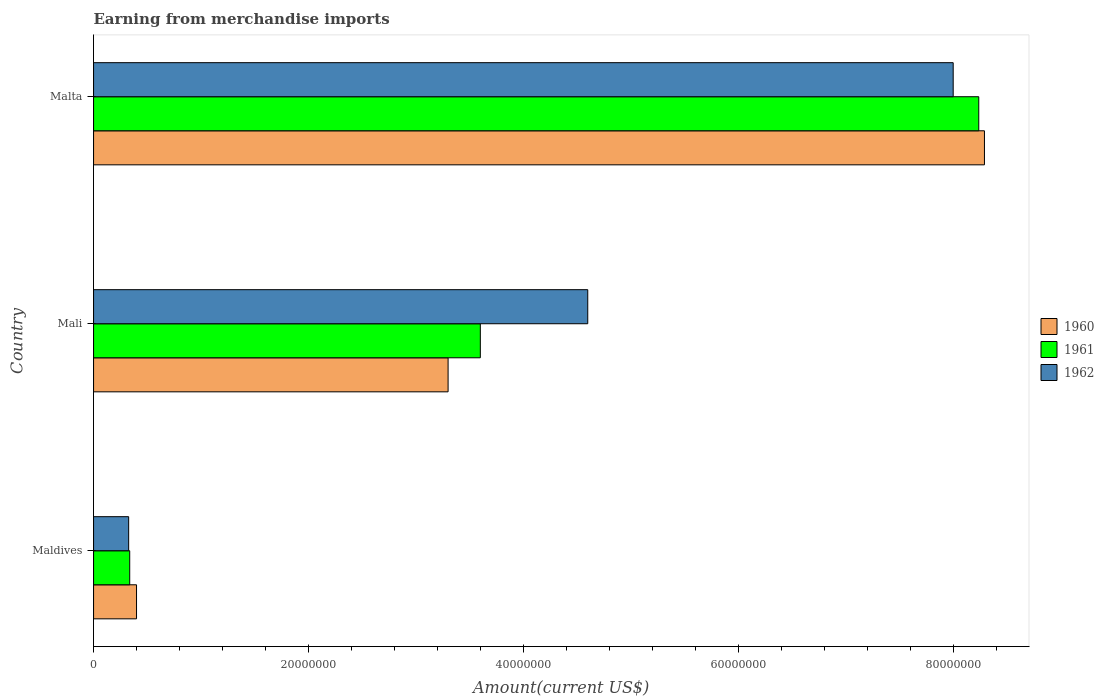How many different coloured bars are there?
Offer a very short reply. 3. Are the number of bars per tick equal to the number of legend labels?
Make the answer very short. Yes. How many bars are there on the 2nd tick from the top?
Your response must be concise. 3. What is the label of the 3rd group of bars from the top?
Give a very brief answer. Maldives. In how many cases, is the number of bars for a given country not equal to the number of legend labels?
Offer a very short reply. 0. What is the amount earned from merchandise imports in 1961 in Malta?
Ensure brevity in your answer.  8.24e+07. Across all countries, what is the maximum amount earned from merchandise imports in 1962?
Your response must be concise. 8.00e+07. Across all countries, what is the minimum amount earned from merchandise imports in 1961?
Offer a terse response. 3.37e+06. In which country was the amount earned from merchandise imports in 1961 maximum?
Make the answer very short. Malta. In which country was the amount earned from merchandise imports in 1961 minimum?
Your response must be concise. Maldives. What is the total amount earned from merchandise imports in 1961 in the graph?
Your answer should be compact. 1.22e+08. What is the difference between the amount earned from merchandise imports in 1961 in Maldives and that in Mali?
Your response must be concise. -3.26e+07. What is the difference between the amount earned from merchandise imports in 1961 in Malta and the amount earned from merchandise imports in 1960 in Mali?
Offer a very short reply. 4.94e+07. What is the average amount earned from merchandise imports in 1961 per country?
Provide a short and direct response. 4.06e+07. What is the difference between the amount earned from merchandise imports in 1962 and amount earned from merchandise imports in 1960 in Mali?
Provide a succinct answer. 1.30e+07. What is the ratio of the amount earned from merchandise imports in 1961 in Mali to that in Malta?
Ensure brevity in your answer.  0.44. Is the amount earned from merchandise imports in 1962 in Maldives less than that in Mali?
Offer a terse response. Yes. Is the difference between the amount earned from merchandise imports in 1962 in Maldives and Mali greater than the difference between the amount earned from merchandise imports in 1960 in Maldives and Mali?
Your answer should be very brief. No. What is the difference between the highest and the second highest amount earned from merchandise imports in 1962?
Make the answer very short. 3.40e+07. What is the difference between the highest and the lowest amount earned from merchandise imports in 1962?
Your answer should be compact. 7.67e+07. Is the sum of the amount earned from merchandise imports in 1962 in Mali and Malta greater than the maximum amount earned from merchandise imports in 1960 across all countries?
Offer a very short reply. Yes. Is it the case that in every country, the sum of the amount earned from merchandise imports in 1962 and amount earned from merchandise imports in 1961 is greater than the amount earned from merchandise imports in 1960?
Offer a very short reply. Yes. How many bars are there?
Your answer should be very brief. 9. What is the difference between two consecutive major ticks on the X-axis?
Your answer should be compact. 2.00e+07. Does the graph contain grids?
Your answer should be very brief. No. Where does the legend appear in the graph?
Offer a terse response. Center right. How are the legend labels stacked?
Ensure brevity in your answer.  Vertical. What is the title of the graph?
Give a very brief answer. Earning from merchandise imports. What is the label or title of the X-axis?
Make the answer very short. Amount(current US$). What is the Amount(current US$) in 1960 in Maldives?
Provide a short and direct response. 4.00e+06. What is the Amount(current US$) in 1961 in Maldives?
Offer a terse response. 3.37e+06. What is the Amount(current US$) in 1962 in Maldives?
Give a very brief answer. 3.27e+06. What is the Amount(current US$) in 1960 in Mali?
Provide a short and direct response. 3.30e+07. What is the Amount(current US$) in 1961 in Mali?
Provide a short and direct response. 3.60e+07. What is the Amount(current US$) of 1962 in Mali?
Keep it short and to the point. 4.60e+07. What is the Amount(current US$) of 1960 in Malta?
Give a very brief answer. 8.29e+07. What is the Amount(current US$) of 1961 in Malta?
Keep it short and to the point. 8.24e+07. What is the Amount(current US$) of 1962 in Malta?
Make the answer very short. 8.00e+07. Across all countries, what is the maximum Amount(current US$) in 1960?
Provide a succinct answer. 8.29e+07. Across all countries, what is the maximum Amount(current US$) of 1961?
Your answer should be compact. 8.24e+07. Across all countries, what is the maximum Amount(current US$) in 1962?
Your answer should be compact. 8.00e+07. Across all countries, what is the minimum Amount(current US$) of 1960?
Ensure brevity in your answer.  4.00e+06. Across all countries, what is the minimum Amount(current US$) of 1961?
Keep it short and to the point. 3.37e+06. Across all countries, what is the minimum Amount(current US$) of 1962?
Offer a very short reply. 3.27e+06. What is the total Amount(current US$) in 1960 in the graph?
Offer a very short reply. 1.20e+08. What is the total Amount(current US$) of 1961 in the graph?
Keep it short and to the point. 1.22e+08. What is the total Amount(current US$) in 1962 in the graph?
Offer a terse response. 1.29e+08. What is the difference between the Amount(current US$) of 1960 in Maldives and that in Mali?
Make the answer very short. -2.90e+07. What is the difference between the Amount(current US$) of 1961 in Maldives and that in Mali?
Make the answer very short. -3.26e+07. What is the difference between the Amount(current US$) in 1962 in Maldives and that in Mali?
Keep it short and to the point. -4.27e+07. What is the difference between the Amount(current US$) of 1960 in Maldives and that in Malta?
Your response must be concise. -7.89e+07. What is the difference between the Amount(current US$) of 1961 in Maldives and that in Malta?
Your answer should be compact. -7.90e+07. What is the difference between the Amount(current US$) in 1962 in Maldives and that in Malta?
Offer a very short reply. -7.67e+07. What is the difference between the Amount(current US$) of 1960 in Mali and that in Malta?
Your answer should be compact. -4.99e+07. What is the difference between the Amount(current US$) in 1961 in Mali and that in Malta?
Your answer should be compact. -4.64e+07. What is the difference between the Amount(current US$) in 1962 in Mali and that in Malta?
Offer a terse response. -3.40e+07. What is the difference between the Amount(current US$) in 1960 in Maldives and the Amount(current US$) in 1961 in Mali?
Offer a terse response. -3.20e+07. What is the difference between the Amount(current US$) in 1960 in Maldives and the Amount(current US$) in 1962 in Mali?
Make the answer very short. -4.20e+07. What is the difference between the Amount(current US$) of 1961 in Maldives and the Amount(current US$) of 1962 in Mali?
Offer a very short reply. -4.26e+07. What is the difference between the Amount(current US$) in 1960 in Maldives and the Amount(current US$) in 1961 in Malta?
Offer a terse response. -7.84e+07. What is the difference between the Amount(current US$) of 1960 in Maldives and the Amount(current US$) of 1962 in Malta?
Give a very brief answer. -7.60e+07. What is the difference between the Amount(current US$) of 1961 in Maldives and the Amount(current US$) of 1962 in Malta?
Make the answer very short. -7.66e+07. What is the difference between the Amount(current US$) in 1960 in Mali and the Amount(current US$) in 1961 in Malta?
Your response must be concise. -4.94e+07. What is the difference between the Amount(current US$) in 1960 in Mali and the Amount(current US$) in 1962 in Malta?
Keep it short and to the point. -4.70e+07. What is the difference between the Amount(current US$) of 1961 in Mali and the Amount(current US$) of 1962 in Malta?
Keep it short and to the point. -4.40e+07. What is the average Amount(current US$) in 1960 per country?
Your answer should be very brief. 4.00e+07. What is the average Amount(current US$) in 1961 per country?
Your answer should be compact. 4.06e+07. What is the average Amount(current US$) in 1962 per country?
Provide a short and direct response. 4.31e+07. What is the difference between the Amount(current US$) of 1960 and Amount(current US$) of 1961 in Maldives?
Make the answer very short. 6.34e+05. What is the difference between the Amount(current US$) of 1960 and Amount(current US$) of 1962 in Maldives?
Ensure brevity in your answer.  7.33e+05. What is the difference between the Amount(current US$) of 1961 and Amount(current US$) of 1962 in Maldives?
Ensure brevity in your answer.  9.90e+04. What is the difference between the Amount(current US$) in 1960 and Amount(current US$) in 1961 in Mali?
Your response must be concise. -3.00e+06. What is the difference between the Amount(current US$) in 1960 and Amount(current US$) in 1962 in Mali?
Keep it short and to the point. -1.30e+07. What is the difference between the Amount(current US$) in 1961 and Amount(current US$) in 1962 in Mali?
Provide a succinct answer. -1.00e+07. What is the difference between the Amount(current US$) in 1960 and Amount(current US$) in 1961 in Malta?
Provide a succinct answer. 5.29e+05. What is the difference between the Amount(current US$) of 1960 and Amount(current US$) of 1962 in Malta?
Ensure brevity in your answer.  2.91e+06. What is the difference between the Amount(current US$) in 1961 and Amount(current US$) in 1962 in Malta?
Your answer should be compact. 2.38e+06. What is the ratio of the Amount(current US$) in 1960 in Maldives to that in Mali?
Your answer should be very brief. 0.12. What is the ratio of the Amount(current US$) of 1961 in Maldives to that in Mali?
Provide a short and direct response. 0.09. What is the ratio of the Amount(current US$) of 1962 in Maldives to that in Mali?
Keep it short and to the point. 0.07. What is the ratio of the Amount(current US$) of 1960 in Maldives to that in Malta?
Make the answer very short. 0.05. What is the ratio of the Amount(current US$) in 1961 in Maldives to that in Malta?
Your response must be concise. 0.04. What is the ratio of the Amount(current US$) of 1962 in Maldives to that in Malta?
Offer a very short reply. 0.04. What is the ratio of the Amount(current US$) in 1960 in Mali to that in Malta?
Your answer should be very brief. 0.4. What is the ratio of the Amount(current US$) of 1961 in Mali to that in Malta?
Offer a terse response. 0.44. What is the ratio of the Amount(current US$) of 1962 in Mali to that in Malta?
Keep it short and to the point. 0.57. What is the difference between the highest and the second highest Amount(current US$) of 1960?
Make the answer very short. 4.99e+07. What is the difference between the highest and the second highest Amount(current US$) of 1961?
Your response must be concise. 4.64e+07. What is the difference between the highest and the second highest Amount(current US$) in 1962?
Your response must be concise. 3.40e+07. What is the difference between the highest and the lowest Amount(current US$) in 1960?
Provide a short and direct response. 7.89e+07. What is the difference between the highest and the lowest Amount(current US$) in 1961?
Provide a succinct answer. 7.90e+07. What is the difference between the highest and the lowest Amount(current US$) of 1962?
Give a very brief answer. 7.67e+07. 